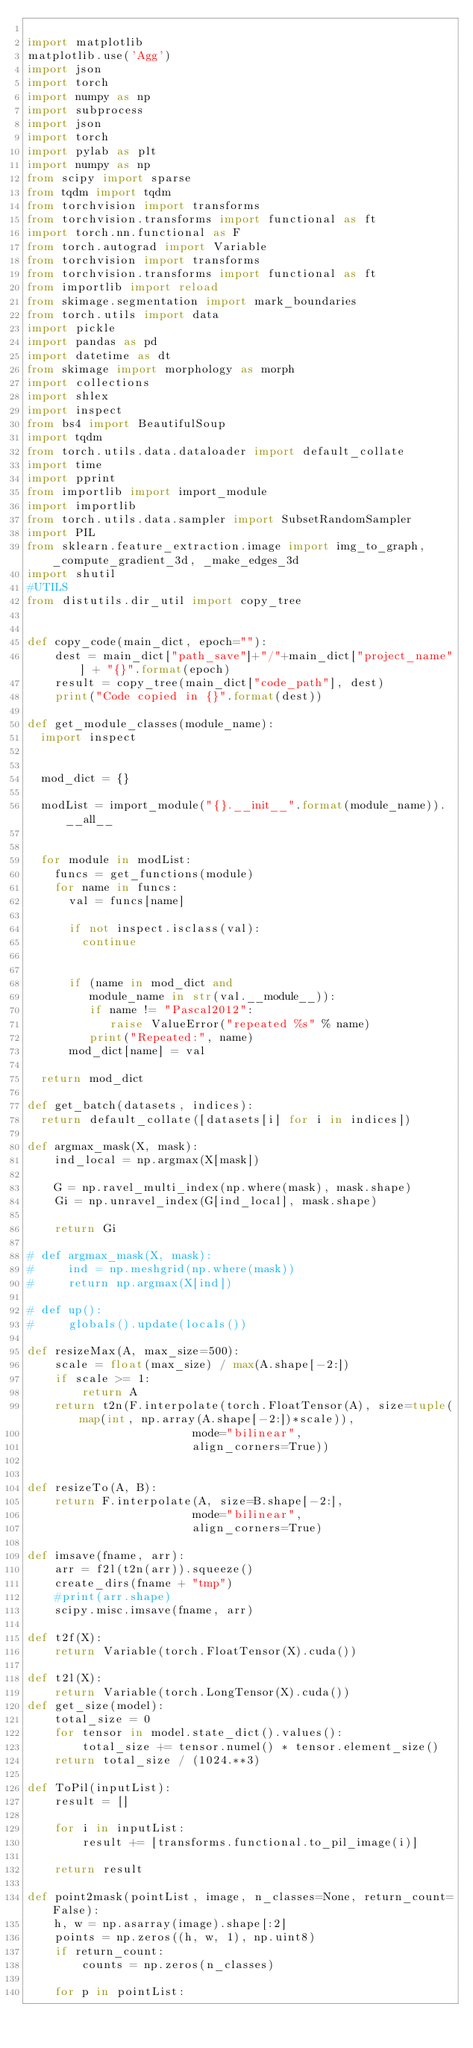Convert code to text. <code><loc_0><loc_0><loc_500><loc_500><_Python_>
import matplotlib
matplotlib.use('Agg')
import json
import torch
import numpy as np
import subprocess
import json
import torch
import pylab as plt
import numpy as np
from scipy import sparse
from tqdm import tqdm 
from torchvision import transforms
from torchvision.transforms import functional as ft
import torch.nn.functional as F
from torch.autograd import Variable
from torchvision import transforms
from torchvision.transforms import functional as ft
from importlib import reload
from skimage.segmentation import mark_boundaries
from torch.utils import data
import pickle 
import pandas as pd
import datetime as dt
from skimage import morphology as morph
import collections
import shlex
import inspect
from bs4 import BeautifulSoup
import tqdm
from torch.utils.data.dataloader import default_collate
import time 
import pprint
from importlib import import_module
import importlib
from torch.utils.data.sampler import SubsetRandomSampler
import PIL
from sklearn.feature_extraction.image import img_to_graph, _compute_gradient_3d, _make_edges_3d
import shutil
#UTILS
from distutils.dir_util import copy_tree


def copy_code(main_dict, epoch=""):
    dest = main_dict["path_save"]+"/"+main_dict["project_name"] + "{}".format(epoch)
    result = copy_tree(main_dict["code_path"], dest) 
    print("Code copied in {}".format(dest))

def get_module_classes(module_name):
  import inspect
  

  mod_dict = {}
  
  modList = import_module("{}.__init__".format(module_name)).__all__


  for module in modList:
    funcs = get_functions(module)
    for name in funcs:
      val = funcs[name]

      if not inspect.isclass(val):
        continue


      if (name in mod_dict and 
         module_name in str(val.__module__)):
         if name != "Pascal2012":
            raise ValueError("repeated %s" % name)
         print("Repeated:", name)
      mod_dict[name] = val

  return mod_dict

def get_batch(datasets, indices):
  return default_collate([datasets[i] for i in indices])

def argmax_mask(X, mask):
    ind_local = np.argmax(X[mask])

    G = np.ravel_multi_index(np.where(mask), mask.shape)
    Gi = np.unravel_index(G[ind_local], mask.shape)
    
    return Gi 

# def argmax_mask(X, mask):
#     ind = np.meshgrid(np.where(mask))
#     return np.argmax(X[ind])

# def up():
#     globals().update(locals())

def resizeMax(A, max_size=500):
    scale = float(max_size) / max(A.shape[-2:])
    if scale >= 1:
        return A
    return t2n(F.interpolate(torch.FloatTensor(A), size=tuple(map(int, np.array(A.shape[-2:])*scale)),
                        mode="bilinear",
                        align_corners=True))


def resizeTo(A, B):
    return F.interpolate(A, size=B.shape[-2:],
                        mode="bilinear",
                        align_corners=True)

def imsave(fname, arr):
    arr = f2l(t2n(arr)).squeeze()
    create_dirs(fname + "tmp")
    #print(arr.shape)
    scipy.misc.imsave(fname, arr)

def t2f(X):
    return Variable(torch.FloatTensor(X).cuda())

def t2l(X):
    return Variable(torch.LongTensor(X).cuda())
def get_size(model):
    total_size = 0
    for tensor in model.state_dict().values():
        total_size += tensor.numel() * tensor.element_size()
    return total_size / (1024.**3)

def ToPil(inputList):
    result = []

    for i in inputList:
        result += [transforms.functional.to_pil_image(i)]

    return result 

def point2mask(pointList, image, n_classes=None, return_count=False):
    h, w = np.asarray(image).shape[:2]
    points = np.zeros((h, w, 1), np.uint8)
    if return_count:
        counts = np.zeros(n_classes)

    for p in pointList: </code> 